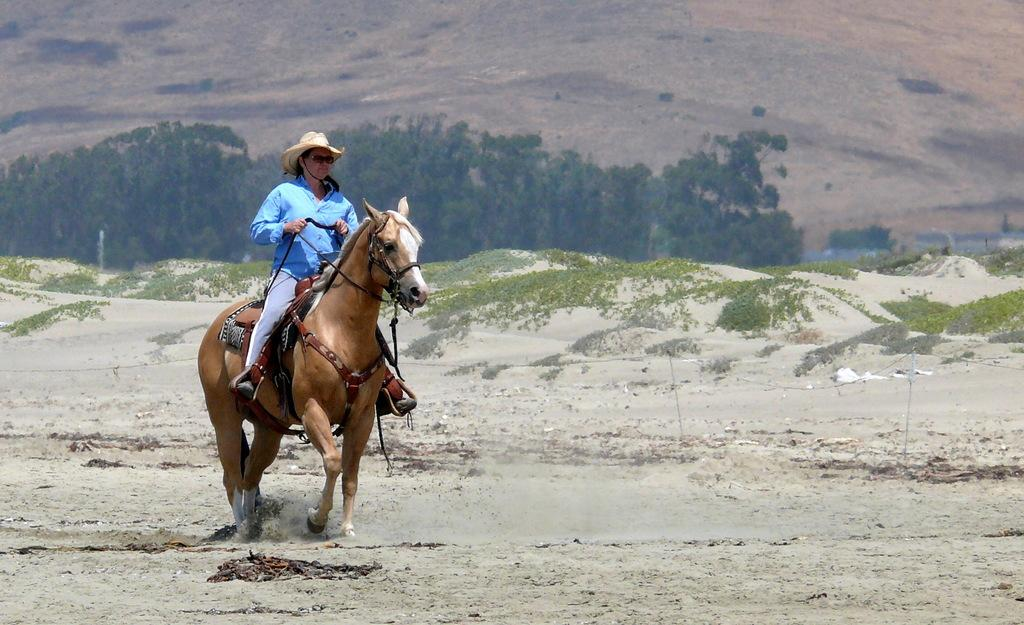Who is present in the image? There is a woman in the image. What is the woman wearing? The woman is wearing a sky blue shirt and a hat. What is the woman doing in the image? The woman is riding a horse. Where is the horse and the woman located? The horse and the woman are on a desert land. What can be seen behind the woman? There are trees behind the woman, and they are in front of a hill. What is the woman's favorite addition to her morning coffee? There is no information about the woman's coffee preferences in the image, so it cannot be determined. 